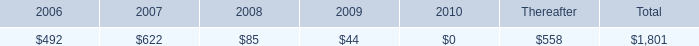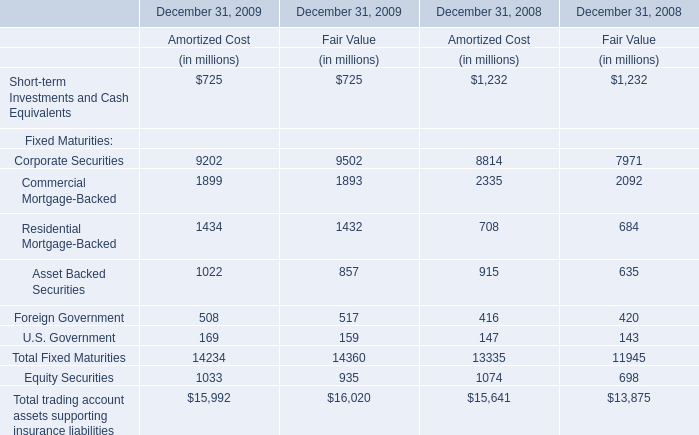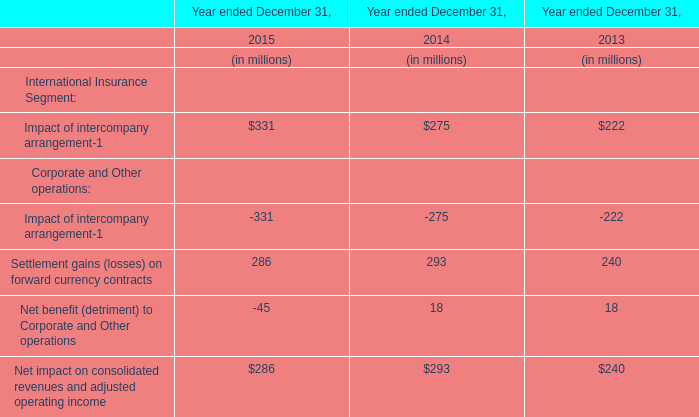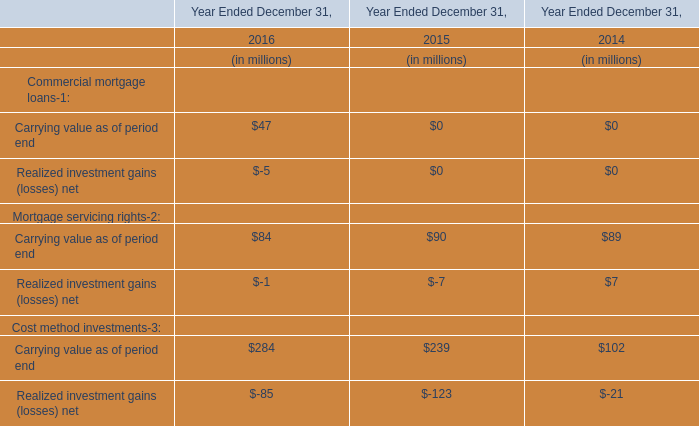What will the Fair Value on December 31 for Equity Securities be like in 2010 if it develops with the same increasing rate as in 2009 ? (in million) 
Computations: (935 * (1 + ((935 - 698) / 698)))
Answer: 1252.47135. 